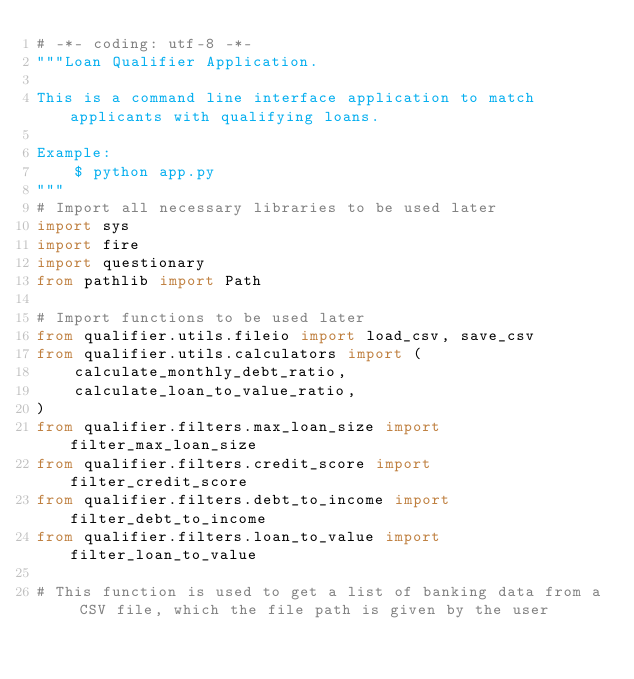<code> <loc_0><loc_0><loc_500><loc_500><_Python_># -*- coding: utf-8 -*-
"""Loan Qualifier Application.

This is a command line interface application to match applicants with qualifying loans.

Example:
    $ python app.py
"""
# Import all necessary libraries to be used later
import sys
import fire
import questionary
from pathlib import Path

# Import functions to be used later
from qualifier.utils.fileio import load_csv, save_csv
from qualifier.utils.calculators import (
    calculate_monthly_debt_ratio,
    calculate_loan_to_value_ratio,
)
from qualifier.filters.max_loan_size import filter_max_loan_size
from qualifier.filters.credit_score import filter_credit_score
from qualifier.filters.debt_to_income import filter_debt_to_income
from qualifier.filters.loan_to_value import filter_loan_to_value

# This function is used to get a list of banking data from a CSV file, which the file path is given by the user</code> 